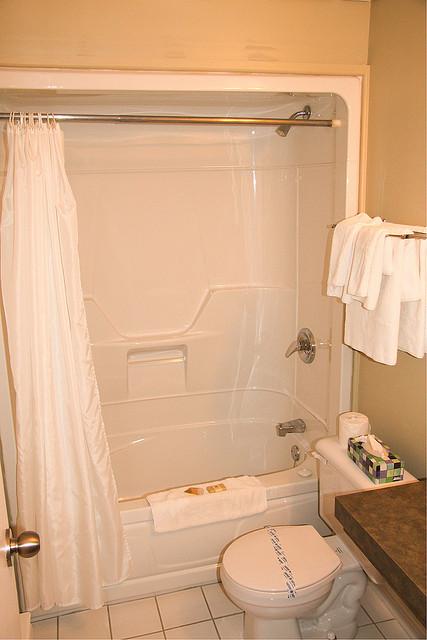Is the bathroom clean?
Be succinct. Yes. What color is dominant?
Quick response, please. White. What is the floor made out of?
Keep it brief. Tile. Is this room cleaned daily?
Keep it brief. Yes. 